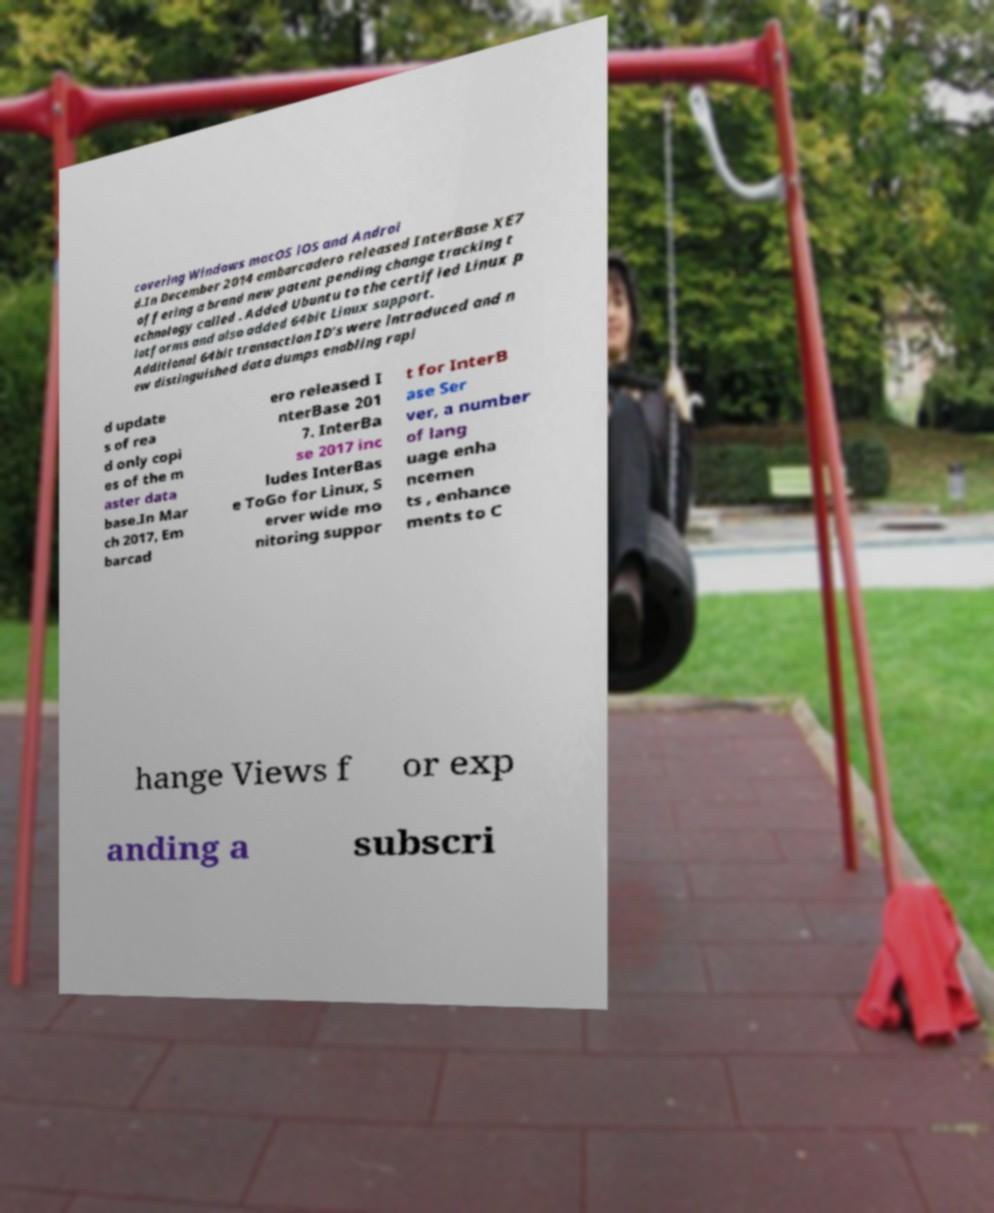Could you extract and type out the text from this image? covering Windows macOS iOS and Androi d.In December 2014 embarcadero released InterBase XE7 offering a brand new patent pending change tracking t echnology called . Added Ubuntu to the certified Linux p latforms and also added 64bit Linux support. Additional 64bit transaction ID's were introduced and n ew distinguished data dumps enabling rapi d update s of rea d only copi es of the m aster data base.In Mar ch 2017, Em barcad ero released I nterBase 201 7. InterBa se 2017 inc ludes InterBas e ToGo for Linux, S erver wide mo nitoring suppor t for InterB ase Ser ver, a number of lang uage enha ncemen ts , enhance ments to C hange Views f or exp anding a subscri 